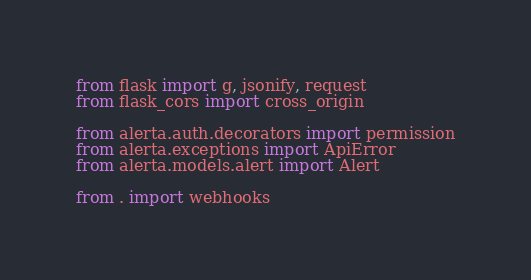<code> <loc_0><loc_0><loc_500><loc_500><_Python_>
from flask import g, jsonify, request
from flask_cors import cross_origin

from alerta.auth.decorators import permission
from alerta.exceptions import ApiError
from alerta.models.alert import Alert

from . import webhooks

</code> 